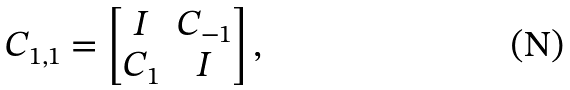<formula> <loc_0><loc_0><loc_500><loc_500>C _ { 1 , 1 } = \left [ \begin{matrix} I & C _ { - 1 } \\ C _ { 1 } & I \end{matrix} \right ] ,</formula> 